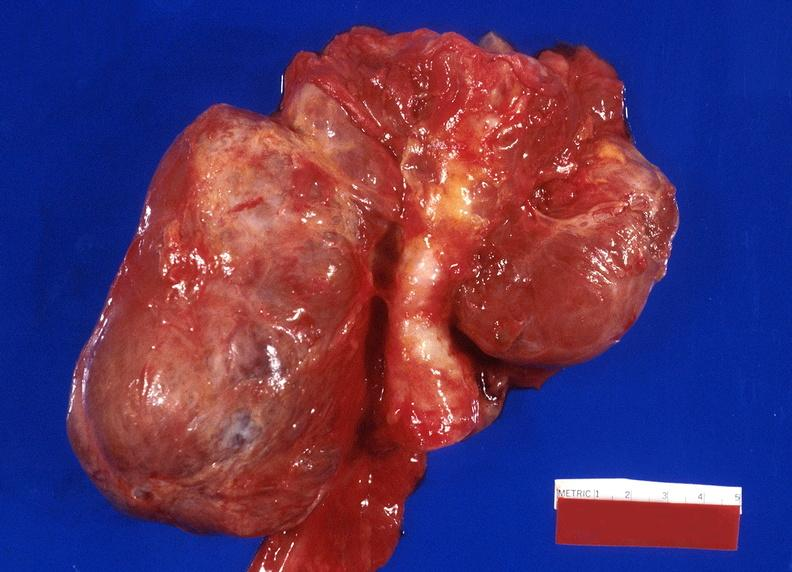s intraductal papillomatosis present?
Answer the question using a single word or phrase. No 